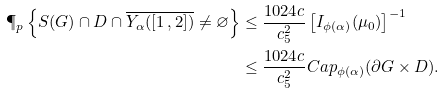Convert formula to latex. <formula><loc_0><loc_0><loc_500><loc_500>\P _ { p } \left \{ S ( G ) \cap D \cap \overline { Y _ { \alpha } ( [ 1 \, , 2 ] ) } \neq \varnothing \right \} & \leq \frac { 1 0 2 4 c } { c _ { 5 } ^ { 2 } } \left [ I _ { \phi ( \alpha ) } ( \mu _ { 0 } ) \right ] ^ { - 1 } \\ & \leq \frac { 1 0 2 4 c } { c _ { 5 } ^ { 2 } } C a p _ { \phi ( \alpha ) } ( \partial G \times D ) .</formula> 